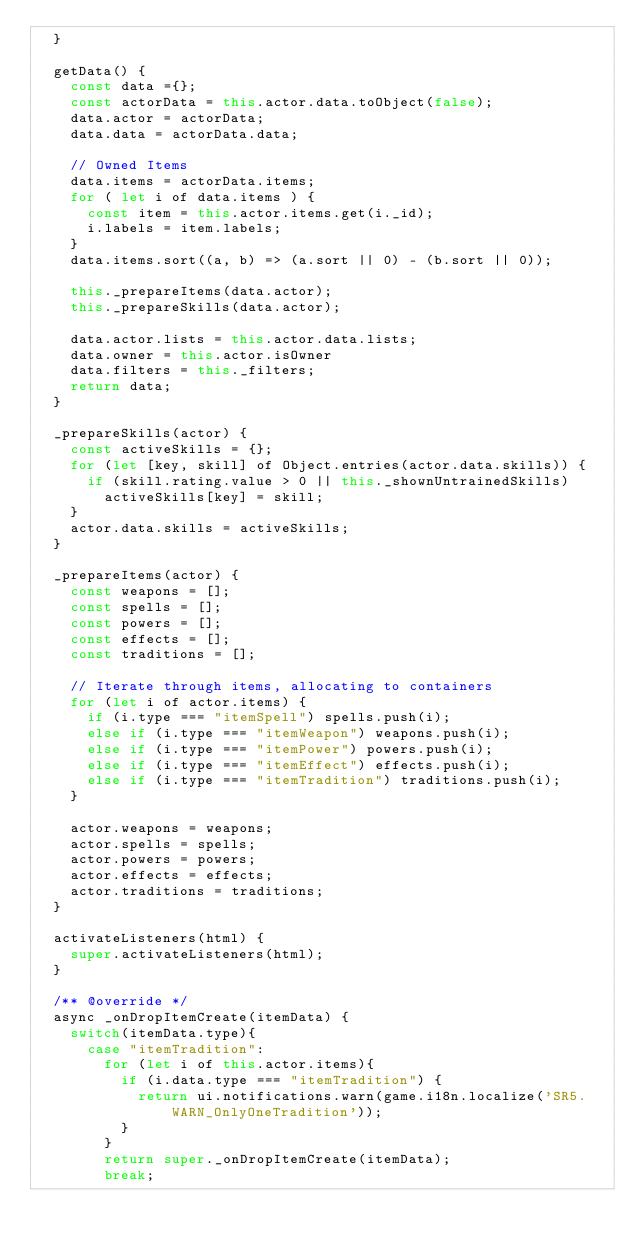Convert code to text. <code><loc_0><loc_0><loc_500><loc_500><_JavaScript_>  }

  getData() {
    const data ={};
    const actorData = this.actor.data.toObject(false);
    data.actor = actorData;
    data.data = actorData.data;

    // Owned Items
    data.items = actorData.items;
    for ( let i of data.items ) {
      const item = this.actor.items.get(i._id);
      i.labels = item.labels;
    }
    data.items.sort((a, b) => (a.sort || 0) - (b.sort || 0));
    
    this._prepareItems(data.actor);
    this._prepareSkills(data.actor);

    data.actor.lists = this.actor.data.lists;
    data.owner = this.actor.isOwner
    data.filters = this._filters;
    return data;
  }

  _prepareSkills(actor) {
    const activeSkills = {};
    for (let [key, skill] of Object.entries(actor.data.skills)) {
      if (skill.rating.value > 0 || this._shownUntrainedSkills)
        activeSkills[key] = skill;
    }
    actor.data.skills = activeSkills;
  }

  _prepareItems(actor) {
    const weapons = [];
    const spells = [];
    const powers = [];
    const effects = [];
    const traditions = [];

    // Iterate through items, allocating to containers
    for (let i of actor.items) {
      if (i.type === "itemSpell") spells.push(i);
      else if (i.type === "itemWeapon") weapons.push(i);
      else if (i.type === "itemPower") powers.push(i);
      else if (i.type === "itemEffect") effects.push(i);
      else if (i.type === "itemTradition") traditions.push(i);
    }

    actor.weapons = weapons;
    actor.spells = spells;
    actor.powers = powers;
    actor.effects = effects;
    actor.traditions = traditions;
  }

  activateListeners(html) {
    super.activateListeners(html);
  }

  /** @override */
  async _onDropItemCreate(itemData) {
    switch(itemData.type){
      case "itemTradition":
        for (let i of this.actor.items){
          if (i.data.type === "itemTradition") {
            return ui.notifications.warn(game.i18n.localize('SR5.WARN_OnlyOneTradition'));
          }
        }
        return super._onDropItemCreate(itemData);
        break;</code> 